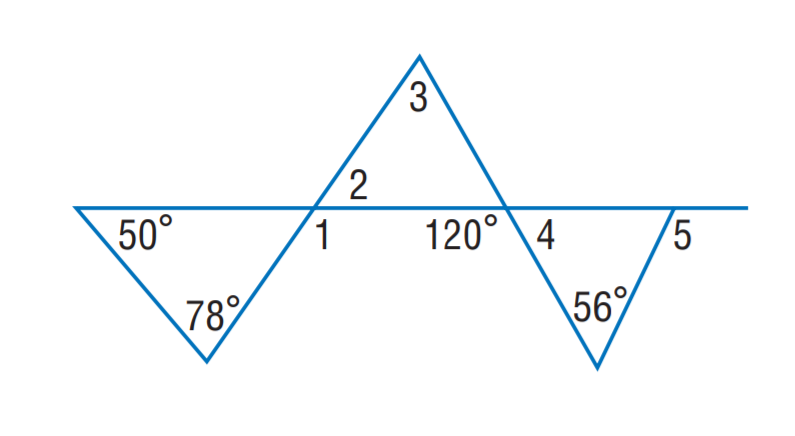Question: Find m \angle 1.
Choices:
A. 78
B. 115
C. 120
D. 128
Answer with the letter. Answer: D Question: Find m \angle 3.
Choices:
A. 56
B. 56
C. 68
D. 78
Answer with the letter. Answer: C Question: Find m \angle 2.
Choices:
A. 50
B. 52
C. 56
D. 68
Answer with the letter. Answer: B 